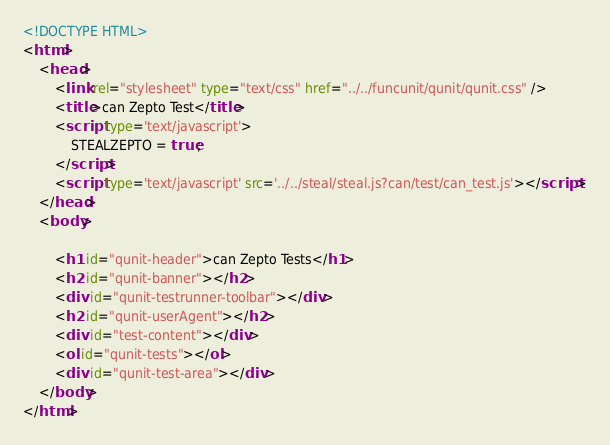<code> <loc_0><loc_0><loc_500><loc_500><_HTML_><!DOCTYPE HTML>
<html>
    <head>
        <link rel="stylesheet" type="text/css" href="../../funcunit/qunit/qunit.css" />
        <title>can Zepto Test</title>
        <script type='text/javascript'>
        	STEALZEPTO = true;
        </script>
		<script type='text/javascript' src='../../steal/steal.js?can/test/can_test.js'></script>
    </head>
    <body>

        <h1 id="qunit-header">can Zepto Tests</h1>
    	<h2 id="qunit-banner"></h2>
    	<div id="qunit-testrunner-toolbar"></div>
    	<h2 id="qunit-userAgent"></h2>
		<div id="test-content"></div>
        <ol id="qunit-tests"></ol>
		<div id="qunit-test-area"></div>
    </body>
</html></code> 